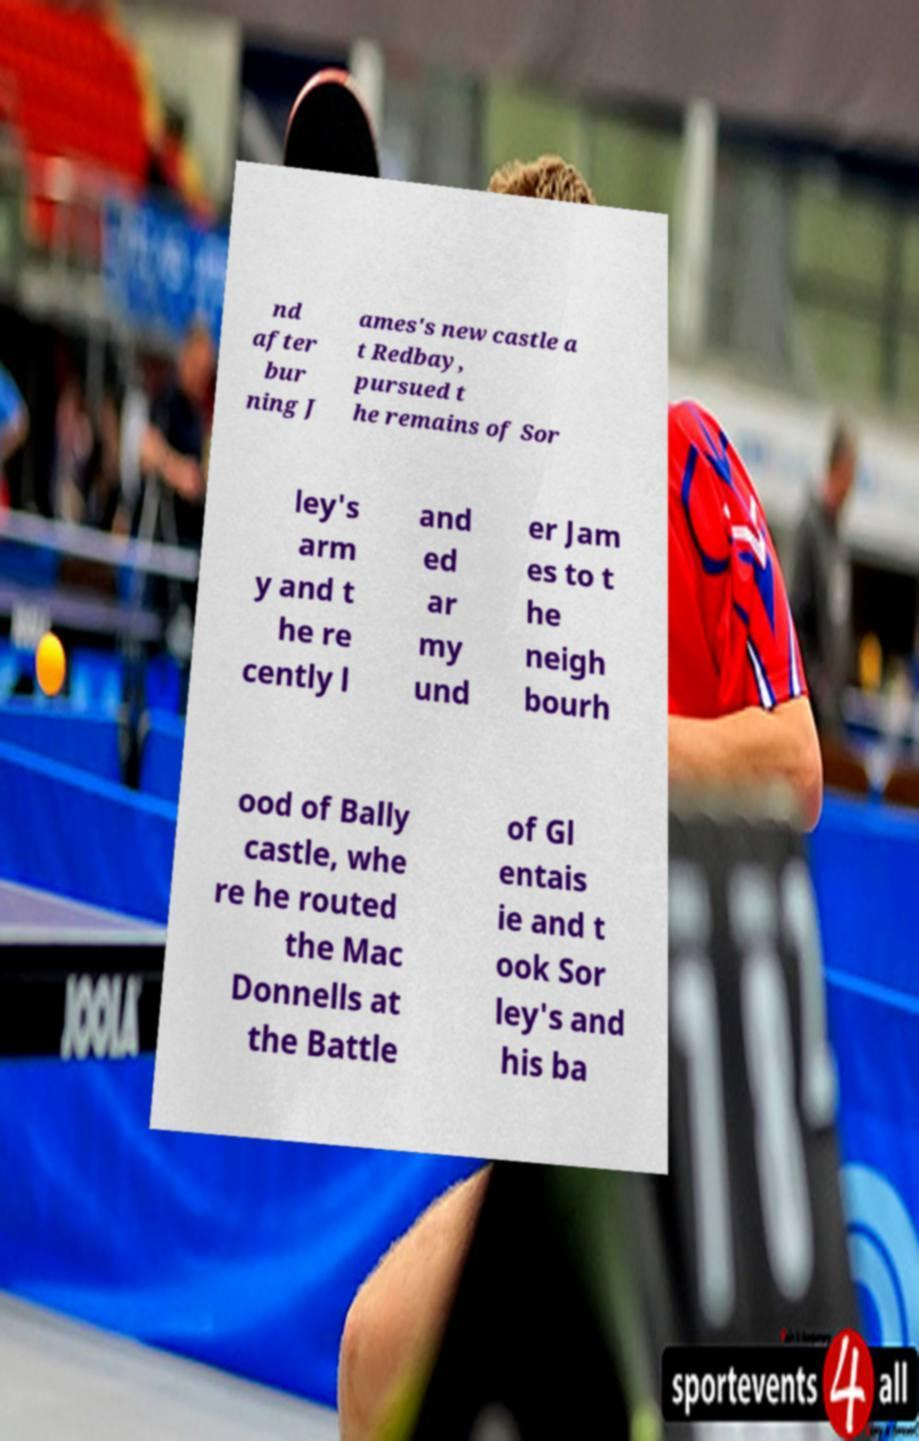Could you assist in decoding the text presented in this image and type it out clearly? nd after bur ning J ames's new castle a t Redbay, pursued t he remains of Sor ley's arm y and t he re cently l and ed ar my und er Jam es to t he neigh bourh ood of Bally castle, whe re he routed the Mac Donnells at the Battle of Gl entais ie and t ook Sor ley's and his ba 